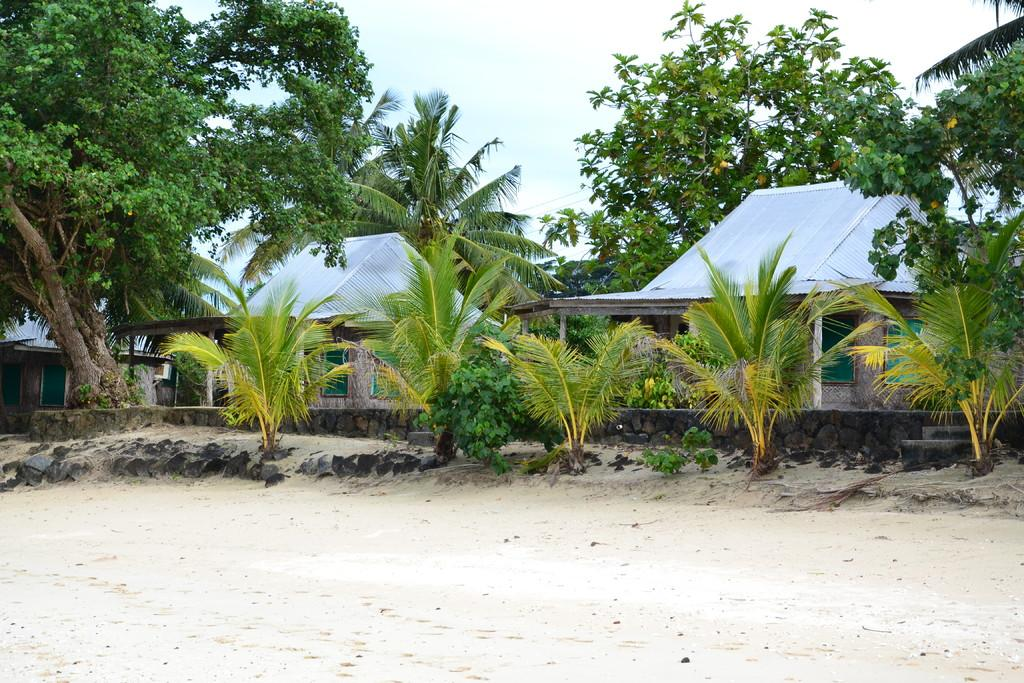What can be seen in the sky in the image? The sky is visible in the image. What type of structures can be seen in the image? There are shelters in the image. What type of natural elements are present in the image? Trees and plants are visible in the image. What is the ground made of in the image? There are stones and sand present on the ground in the image. What color are the windows visible in the distance? Green windows are visible in the distance. What type of ball is being used to pump air into the trees in the image? There is no ball or pump present in the image; the trees are not being inflated. 